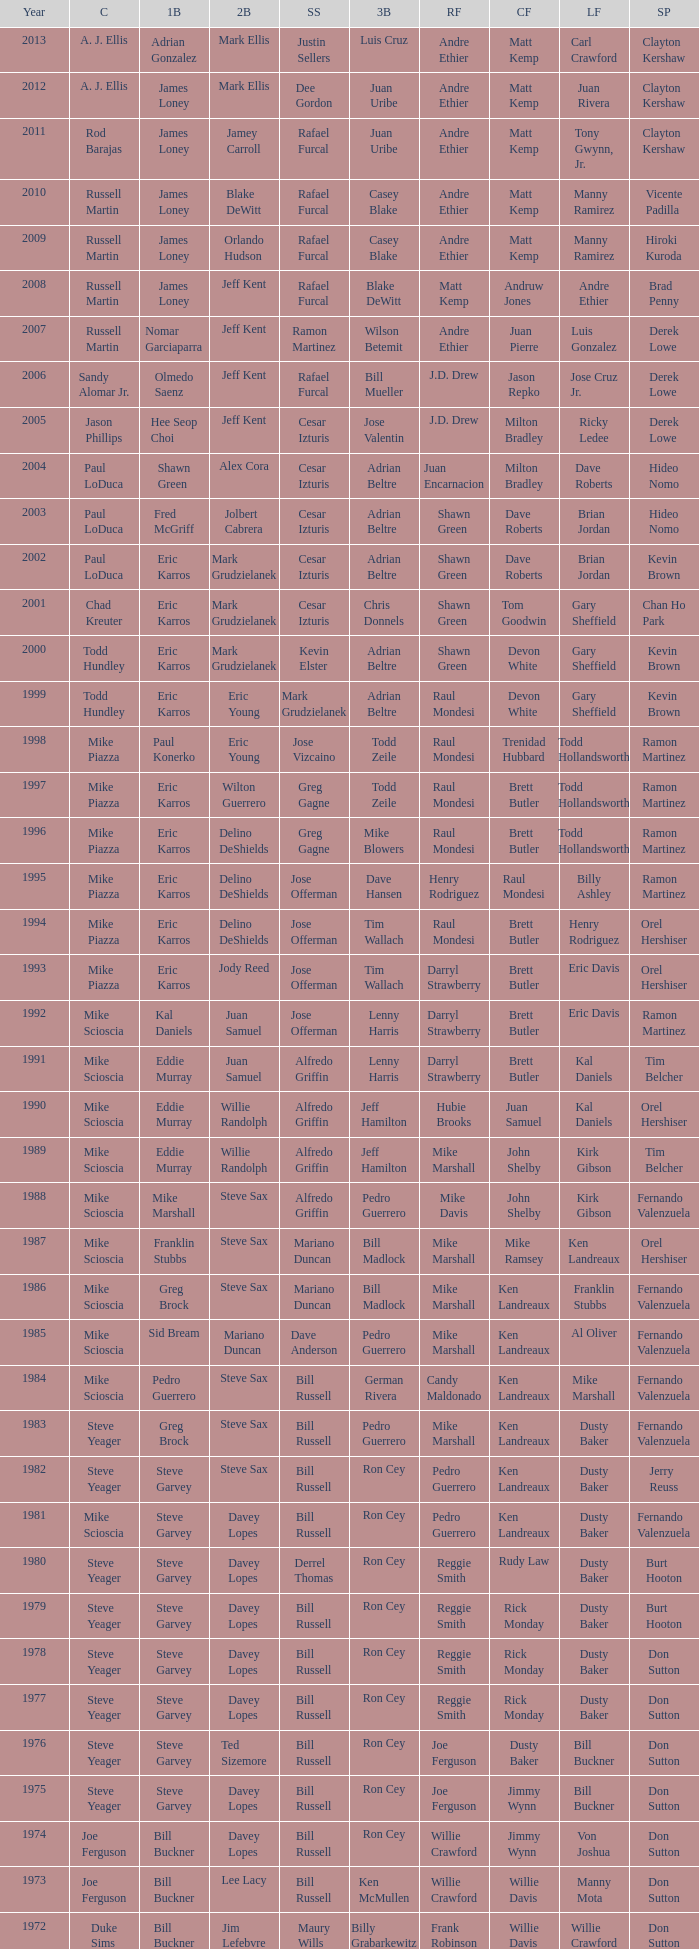Would you mind parsing the complete table? {'header': ['Year', 'C', '1B', '2B', 'SS', '3B', 'RF', 'CF', 'LF', 'SP'], 'rows': [['2013', 'A. J. Ellis', 'Adrian Gonzalez', 'Mark Ellis', 'Justin Sellers', 'Luis Cruz', 'Andre Ethier', 'Matt Kemp', 'Carl Crawford', 'Clayton Kershaw'], ['2012', 'A. J. Ellis', 'James Loney', 'Mark Ellis', 'Dee Gordon', 'Juan Uribe', 'Andre Ethier', 'Matt Kemp', 'Juan Rivera', 'Clayton Kershaw'], ['2011', 'Rod Barajas', 'James Loney', 'Jamey Carroll', 'Rafael Furcal', 'Juan Uribe', 'Andre Ethier', 'Matt Kemp', 'Tony Gwynn, Jr.', 'Clayton Kershaw'], ['2010', 'Russell Martin', 'James Loney', 'Blake DeWitt', 'Rafael Furcal', 'Casey Blake', 'Andre Ethier', 'Matt Kemp', 'Manny Ramirez', 'Vicente Padilla'], ['2009', 'Russell Martin', 'James Loney', 'Orlando Hudson', 'Rafael Furcal', 'Casey Blake', 'Andre Ethier', 'Matt Kemp', 'Manny Ramirez', 'Hiroki Kuroda'], ['2008', 'Russell Martin', 'James Loney', 'Jeff Kent', 'Rafael Furcal', 'Blake DeWitt', 'Matt Kemp', 'Andruw Jones', 'Andre Ethier', 'Brad Penny'], ['2007', 'Russell Martin', 'Nomar Garciaparra', 'Jeff Kent', 'Ramon Martinez', 'Wilson Betemit', 'Andre Ethier', 'Juan Pierre', 'Luis Gonzalez', 'Derek Lowe'], ['2006', 'Sandy Alomar Jr.', 'Olmedo Saenz', 'Jeff Kent', 'Rafael Furcal', 'Bill Mueller', 'J.D. Drew', 'Jason Repko', 'Jose Cruz Jr.', 'Derek Lowe'], ['2005', 'Jason Phillips', 'Hee Seop Choi', 'Jeff Kent', 'Cesar Izturis', 'Jose Valentin', 'J.D. Drew', 'Milton Bradley', 'Ricky Ledee', 'Derek Lowe'], ['2004', 'Paul LoDuca', 'Shawn Green', 'Alex Cora', 'Cesar Izturis', 'Adrian Beltre', 'Juan Encarnacion', 'Milton Bradley', 'Dave Roberts', 'Hideo Nomo'], ['2003', 'Paul LoDuca', 'Fred McGriff', 'Jolbert Cabrera', 'Cesar Izturis', 'Adrian Beltre', 'Shawn Green', 'Dave Roberts', 'Brian Jordan', 'Hideo Nomo'], ['2002', 'Paul LoDuca', 'Eric Karros', 'Mark Grudzielanek', 'Cesar Izturis', 'Adrian Beltre', 'Shawn Green', 'Dave Roberts', 'Brian Jordan', 'Kevin Brown'], ['2001', 'Chad Kreuter', 'Eric Karros', 'Mark Grudzielanek', 'Cesar Izturis', 'Chris Donnels', 'Shawn Green', 'Tom Goodwin', 'Gary Sheffield', 'Chan Ho Park'], ['2000', 'Todd Hundley', 'Eric Karros', 'Mark Grudzielanek', 'Kevin Elster', 'Adrian Beltre', 'Shawn Green', 'Devon White', 'Gary Sheffield', 'Kevin Brown'], ['1999', 'Todd Hundley', 'Eric Karros', 'Eric Young', 'Mark Grudzielanek', 'Adrian Beltre', 'Raul Mondesi', 'Devon White', 'Gary Sheffield', 'Kevin Brown'], ['1998', 'Mike Piazza', 'Paul Konerko', 'Eric Young', 'Jose Vizcaino', 'Todd Zeile', 'Raul Mondesi', 'Trenidad Hubbard', 'Todd Hollandsworth', 'Ramon Martinez'], ['1997', 'Mike Piazza', 'Eric Karros', 'Wilton Guerrero', 'Greg Gagne', 'Todd Zeile', 'Raul Mondesi', 'Brett Butler', 'Todd Hollandsworth', 'Ramon Martinez'], ['1996', 'Mike Piazza', 'Eric Karros', 'Delino DeShields', 'Greg Gagne', 'Mike Blowers', 'Raul Mondesi', 'Brett Butler', 'Todd Hollandsworth', 'Ramon Martinez'], ['1995', 'Mike Piazza', 'Eric Karros', 'Delino DeShields', 'Jose Offerman', 'Dave Hansen', 'Henry Rodriguez', 'Raul Mondesi', 'Billy Ashley', 'Ramon Martinez'], ['1994', 'Mike Piazza', 'Eric Karros', 'Delino DeShields', 'Jose Offerman', 'Tim Wallach', 'Raul Mondesi', 'Brett Butler', 'Henry Rodriguez', 'Orel Hershiser'], ['1993', 'Mike Piazza', 'Eric Karros', 'Jody Reed', 'Jose Offerman', 'Tim Wallach', 'Darryl Strawberry', 'Brett Butler', 'Eric Davis', 'Orel Hershiser'], ['1992', 'Mike Scioscia', 'Kal Daniels', 'Juan Samuel', 'Jose Offerman', 'Lenny Harris', 'Darryl Strawberry', 'Brett Butler', 'Eric Davis', 'Ramon Martinez'], ['1991', 'Mike Scioscia', 'Eddie Murray', 'Juan Samuel', 'Alfredo Griffin', 'Lenny Harris', 'Darryl Strawberry', 'Brett Butler', 'Kal Daniels', 'Tim Belcher'], ['1990', 'Mike Scioscia', 'Eddie Murray', 'Willie Randolph', 'Alfredo Griffin', 'Jeff Hamilton', 'Hubie Brooks', 'Juan Samuel', 'Kal Daniels', 'Orel Hershiser'], ['1989', 'Mike Scioscia', 'Eddie Murray', 'Willie Randolph', 'Alfredo Griffin', 'Jeff Hamilton', 'Mike Marshall', 'John Shelby', 'Kirk Gibson', 'Tim Belcher'], ['1988', 'Mike Scioscia', 'Mike Marshall', 'Steve Sax', 'Alfredo Griffin', 'Pedro Guerrero', 'Mike Davis', 'John Shelby', 'Kirk Gibson', 'Fernando Valenzuela'], ['1987', 'Mike Scioscia', 'Franklin Stubbs', 'Steve Sax', 'Mariano Duncan', 'Bill Madlock', 'Mike Marshall', 'Mike Ramsey', 'Ken Landreaux', 'Orel Hershiser'], ['1986', 'Mike Scioscia', 'Greg Brock', 'Steve Sax', 'Mariano Duncan', 'Bill Madlock', 'Mike Marshall', 'Ken Landreaux', 'Franklin Stubbs', 'Fernando Valenzuela'], ['1985', 'Mike Scioscia', 'Sid Bream', 'Mariano Duncan', 'Dave Anderson', 'Pedro Guerrero', 'Mike Marshall', 'Ken Landreaux', 'Al Oliver', 'Fernando Valenzuela'], ['1984', 'Mike Scioscia', 'Pedro Guerrero', 'Steve Sax', 'Bill Russell', 'German Rivera', 'Candy Maldonado', 'Ken Landreaux', 'Mike Marshall', 'Fernando Valenzuela'], ['1983', 'Steve Yeager', 'Greg Brock', 'Steve Sax', 'Bill Russell', 'Pedro Guerrero', 'Mike Marshall', 'Ken Landreaux', 'Dusty Baker', 'Fernando Valenzuela'], ['1982', 'Steve Yeager', 'Steve Garvey', 'Steve Sax', 'Bill Russell', 'Ron Cey', 'Pedro Guerrero', 'Ken Landreaux', 'Dusty Baker', 'Jerry Reuss'], ['1981', 'Mike Scioscia', 'Steve Garvey', 'Davey Lopes', 'Bill Russell', 'Ron Cey', 'Pedro Guerrero', 'Ken Landreaux', 'Dusty Baker', 'Fernando Valenzuela'], ['1980', 'Steve Yeager', 'Steve Garvey', 'Davey Lopes', 'Derrel Thomas', 'Ron Cey', 'Reggie Smith', 'Rudy Law', 'Dusty Baker', 'Burt Hooton'], ['1979', 'Steve Yeager', 'Steve Garvey', 'Davey Lopes', 'Bill Russell', 'Ron Cey', 'Reggie Smith', 'Rick Monday', 'Dusty Baker', 'Burt Hooton'], ['1978', 'Steve Yeager', 'Steve Garvey', 'Davey Lopes', 'Bill Russell', 'Ron Cey', 'Reggie Smith', 'Rick Monday', 'Dusty Baker', 'Don Sutton'], ['1977', 'Steve Yeager', 'Steve Garvey', 'Davey Lopes', 'Bill Russell', 'Ron Cey', 'Reggie Smith', 'Rick Monday', 'Dusty Baker', 'Don Sutton'], ['1976', 'Steve Yeager', 'Steve Garvey', 'Ted Sizemore', 'Bill Russell', 'Ron Cey', 'Joe Ferguson', 'Dusty Baker', 'Bill Buckner', 'Don Sutton'], ['1975', 'Steve Yeager', 'Steve Garvey', 'Davey Lopes', 'Bill Russell', 'Ron Cey', 'Joe Ferguson', 'Jimmy Wynn', 'Bill Buckner', 'Don Sutton'], ['1974', 'Joe Ferguson', 'Bill Buckner', 'Davey Lopes', 'Bill Russell', 'Ron Cey', 'Willie Crawford', 'Jimmy Wynn', 'Von Joshua', 'Don Sutton'], ['1973', 'Joe Ferguson', 'Bill Buckner', 'Lee Lacy', 'Bill Russell', 'Ken McMullen', 'Willie Crawford', 'Willie Davis', 'Manny Mota', 'Don Sutton'], ['1972', 'Duke Sims', 'Bill Buckner', 'Jim Lefebvre', 'Maury Wills', 'Billy Grabarkewitz', 'Frank Robinson', 'Willie Davis', 'Willie Crawford', 'Don Sutton'], ['1971', 'Duke Sims', 'Wes Parker', 'Bill Russell', 'Maury Wills', 'Steve Garvey', 'Bill Buckner', 'Willie Davis', 'Dick Allen', 'Bill Singer'], ['1970', 'Tom Haller', 'Wes Parker', 'Ted Sizemore', 'Maury Wills', 'Steve Garvey', 'Willie Crawford', 'Willie Davis', 'Bill Buckner', 'Claude Osteen'], ['1969', 'Tom Haller', 'Ron Fairly', 'Jim Lefebvre', 'Ted Sizemore', 'Bill Sudakis', 'Len Gabrielson', 'Willie Crawford', 'Andy Kosco', 'Don Drysdale'], ['1968', 'Tom Haller', 'Wes Parker', 'Paul Popovich', 'Zoilo Versalles', 'Bob Bailey', 'Ron Fairly', 'Willie Davis', 'Al Ferrara', 'Claude Osteen'], ['1967', 'Johnny Roseboro', 'Ron Fairly', 'Ron Hunt', 'Gene Michael', 'Jim Lefebvre', 'Lou Johnson', 'Wes Parker', 'Bob Bailey', 'Bob Miller'], ['1966', 'Johnny Roseboro', 'Wes Parker', 'Nate Oliver', 'Maury Wills', 'Jim Lefebvre', 'Ron Fairly', 'Willie Davis', 'Lou Johnson', 'Claude Osteen'], ['1965', 'Johnny Roseboro', 'Wes Parker', 'Jim Lefebvre', 'Maury Wills', 'John Kennedy', 'Ron Fairly', 'Willie Davis', 'Tommy Davis', 'Don Drysdale'], ['1964', 'Johnny Roseboro', 'Ron Fairly', 'Jim Gilliam', 'Maury Wills', 'Johnny Werhas', 'Frank Howard', 'Willie Davis', 'Tommy Davis', 'Sandy Koufax'], ['1963', 'Johnny Roseboro', 'Bill Skowron', 'Nate Oliver', 'Maury Wills', 'Ken McMullen', 'Ron Fairly', 'Willie Davis', 'Tommy Davis', 'Don Drysdale'], ['1962', 'Johnny Roseboro', 'Ron Fairly', 'Jim Gilliam', 'Maury Wills', 'Daryl Spencer', 'Duke Snider', 'Willie Davis', 'Wally Moon', 'Johnny Podres'], ['1961', 'Johnny Roseboro', 'Norm Larker', 'Charlie Neal', 'Maury Wills', 'Tommy Davis', 'Duke Snider', 'Willie Davis', 'Wally Moon', 'Don Drysdale'], ['1960', 'Johnny Roseboro', 'Gil Hodges', 'Charlie Neal', 'Maury Wills', 'Jim Gilliam', 'Duke Snider', 'Don Demeter', 'Wally Moon', 'Don Drysdale'], ['1959', 'Johnny Roseboro', 'Gil Hodges', 'Charlie Neal', 'Don Zimmer', 'Jim Baxes', 'Ron Fairly', 'Duke Snider', 'Wally Moon', 'Don Drysdale']]} Who played 2nd base when nomar garciaparra was at 1st base? Jeff Kent. 